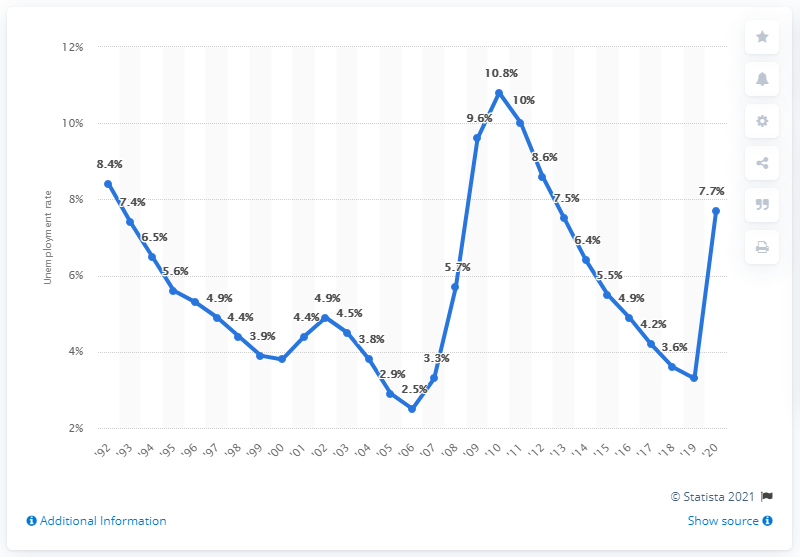Draw attention to some important aspects in this diagram. The previous unemployment rate in Florida was 3.3%. The unemployment rate in Florida decreased from 5.2% in 2006 to 3.7% in 2020. In 2006, the unemployment rate in Florida was the lowest it had been. The unemployment rate in Florida in 2020 was 7.7%. 